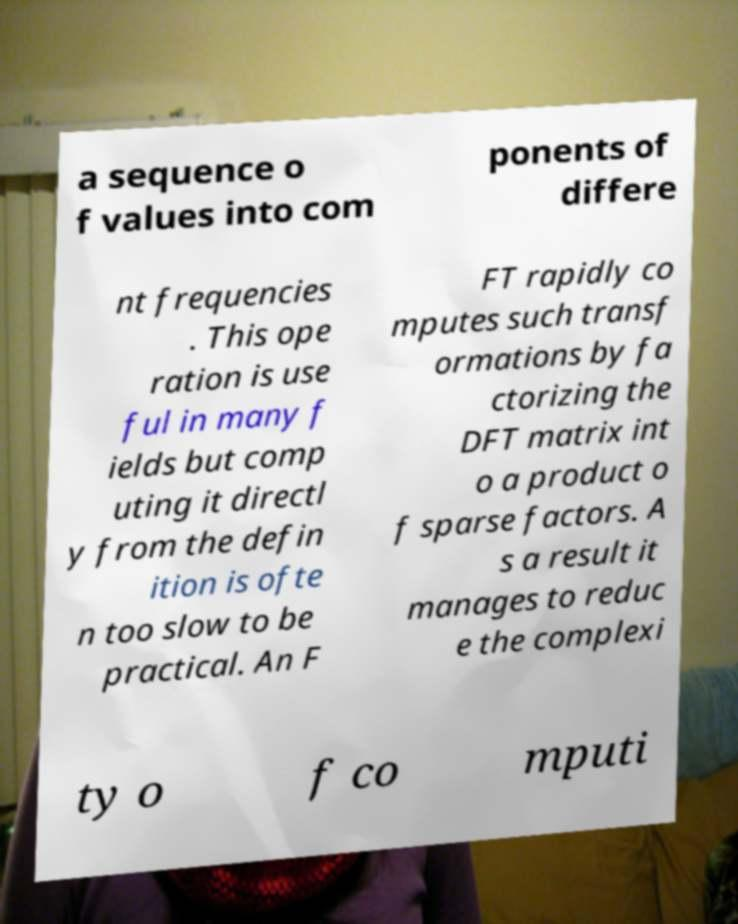Could you assist in decoding the text presented in this image and type it out clearly? a sequence o f values into com ponents of differe nt frequencies . This ope ration is use ful in many f ields but comp uting it directl y from the defin ition is ofte n too slow to be practical. An F FT rapidly co mputes such transf ormations by fa ctorizing the DFT matrix int o a product o f sparse factors. A s a result it manages to reduc e the complexi ty o f co mputi 